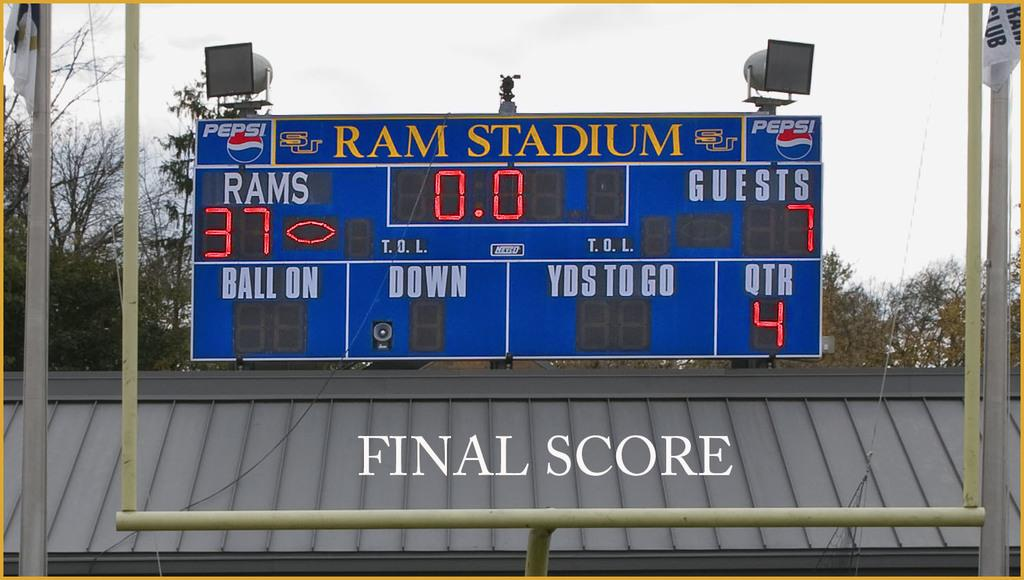Provide a one-sentence caption for the provided image. Ram stadium scoreboard with a score of 37 Rams and 7 guests. 